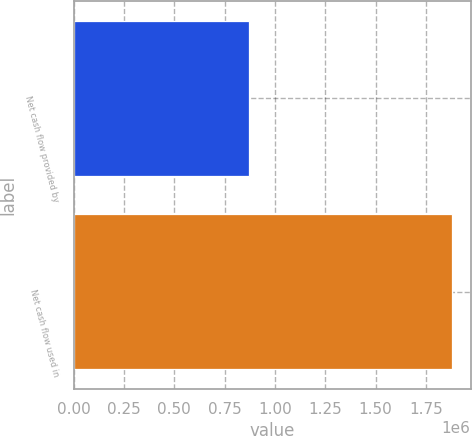Convert chart. <chart><loc_0><loc_0><loc_500><loc_500><bar_chart><fcel>Net cash flow provided by<fcel>Net cash flow used in<nl><fcel>869130<fcel>1.87788e+06<nl></chart> 